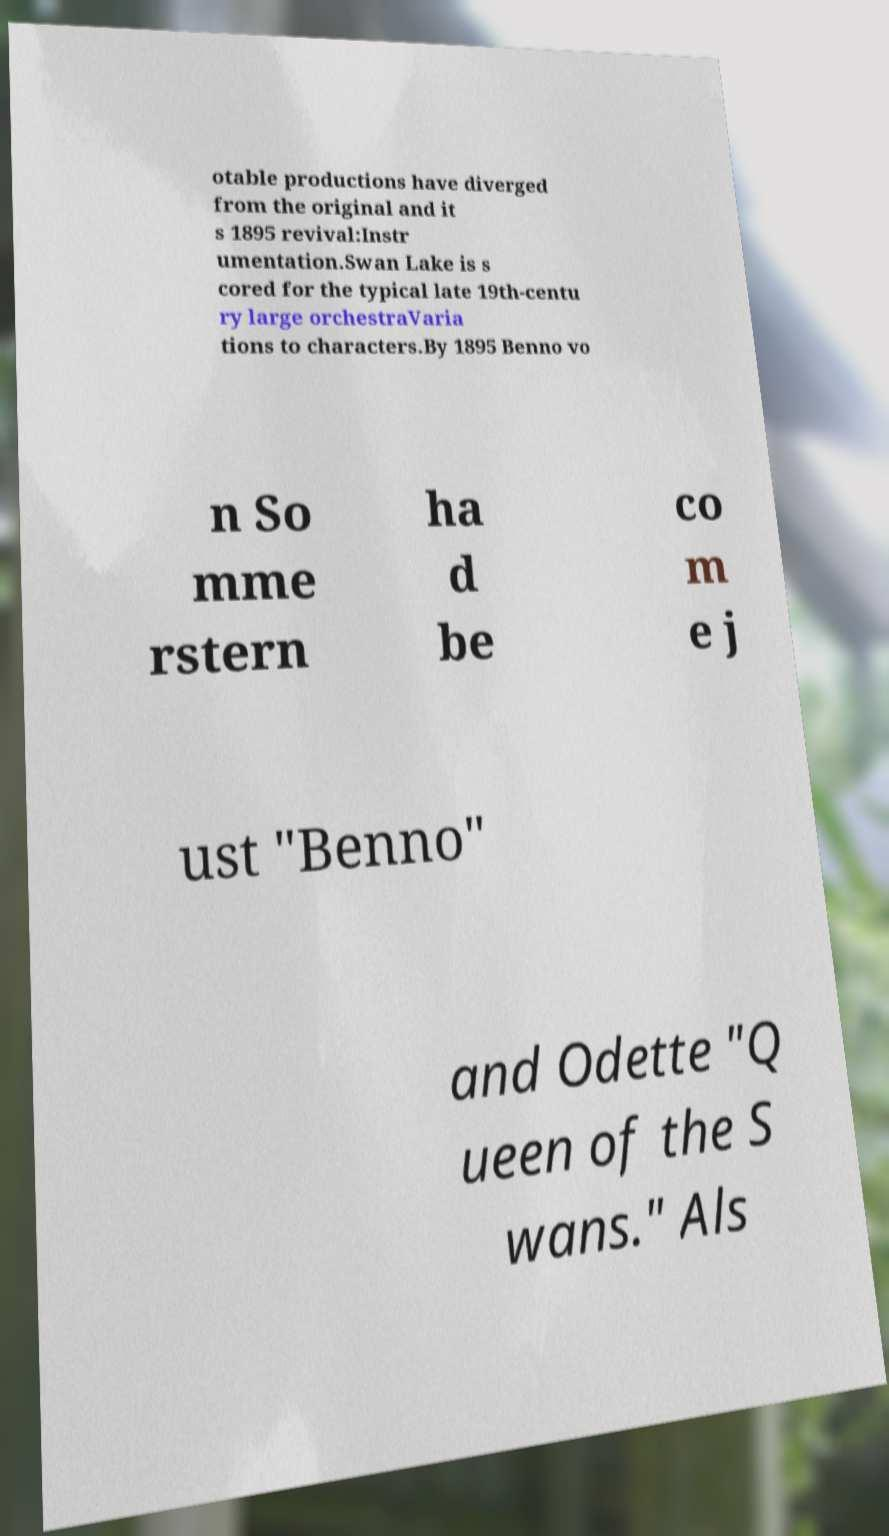Please identify and transcribe the text found in this image. otable productions have diverged from the original and it s 1895 revival:Instr umentation.Swan Lake is s cored for the typical late 19th-centu ry large orchestraVaria tions to characters.By 1895 Benno vo n So mme rstern ha d be co m e j ust "Benno" and Odette "Q ueen of the S wans." Als 